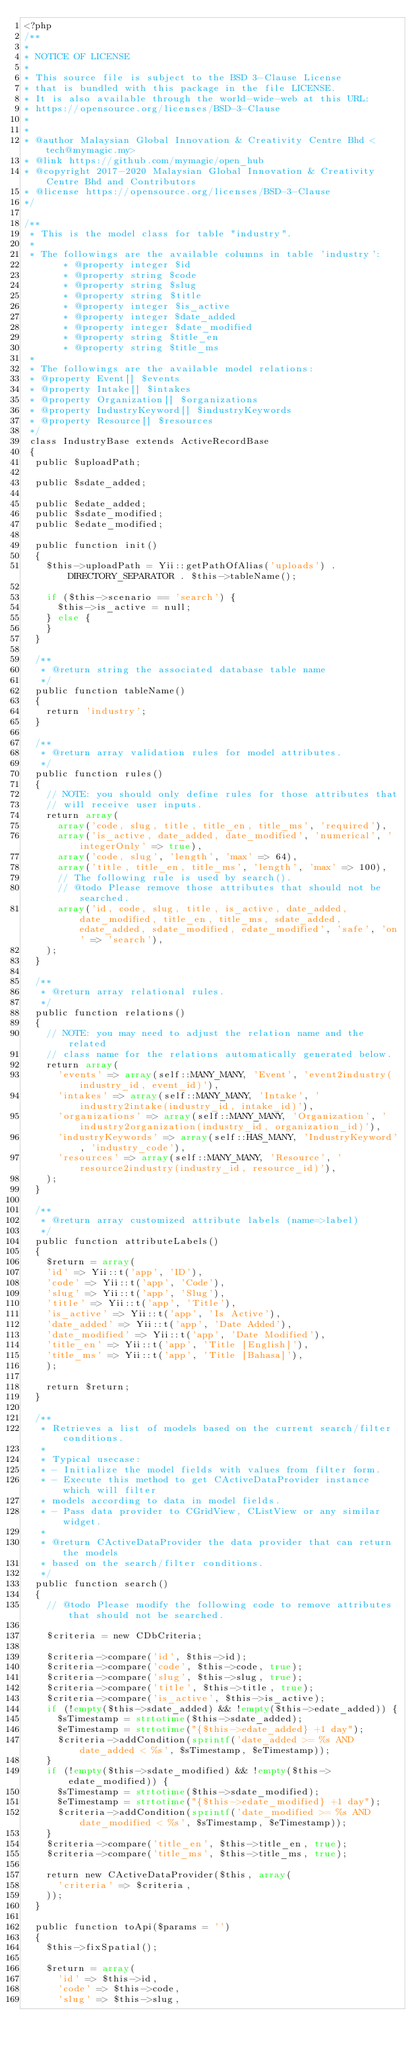Convert code to text. <code><loc_0><loc_0><loc_500><loc_500><_PHP_><?php
/**
*
* NOTICE OF LICENSE
*
* This source file is subject to the BSD 3-Clause License
* that is bundled with this package in the file LICENSE.
* It is also available through the world-wide-web at this URL:
* https://opensource.org/licenses/BSD-3-Clause
*
*
* @author Malaysian Global Innovation & Creativity Centre Bhd <tech@mymagic.my>
* @link https://github.com/mymagic/open_hub
* @copyright 2017-2020 Malaysian Global Innovation & Creativity Centre Bhd and Contributors
* @license https://opensource.org/licenses/BSD-3-Clause
*/

/**
 * This is the model class for table "industry".
 *
 * The followings are the available columns in table 'industry':
			 * @property integer $id
			 * @property string $code
			 * @property string $slug
			 * @property string $title
			 * @property integer $is_active
			 * @property integer $date_added
			 * @property integer $date_modified
			 * @property string $title_en
			 * @property string $title_ms
 *
 * The followings are the available model relations:
 * @property Event[] $events
 * @property Intake[] $intakes
 * @property Organization[] $organizations
 * @property IndustryKeyword[] $industryKeywords
 * @property Resource[] $resources
 */
 class IndustryBase extends ActiveRecordBase
 {
 	public $uploadPath;

 	public $sdate_added;

 	public $edate_added;
 	public $sdate_modified;
 	public $edate_modified;

 	public function init()
 	{
 		$this->uploadPath = Yii::getPathOfAlias('uploads') . DIRECTORY_SEPARATOR . $this->tableName();

 		if ($this->scenario == 'search') {
 			$this->is_active = null;
 		} else {
 		}
 	}

 	/**
 	 * @return string the associated database table name
 	 */
 	public function tableName()
 	{
 		return 'industry';
 	}

 	/**
 	 * @return array validation rules for model attributes.
 	 */
 	public function rules()
 	{
 		// NOTE: you should only define rules for those attributes that
 		// will receive user inputs.
 		return array(
			array('code, slug, title, title_en, title_ms', 'required'),
			array('is_active, date_added, date_modified', 'numerical', 'integerOnly' => true),
			array('code, slug', 'length', 'max' => 64),
			array('title, title_en, title_ms', 'length', 'max' => 100),
			// The following rule is used by search().
			// @todo Please remove those attributes that should not be searched.
			array('id, code, slug, title, is_active, date_added, date_modified, title_en, title_ms, sdate_added, edate_added, sdate_modified, edate_modified', 'safe', 'on' => 'search'),
		);
 	}

 	/**
 	 * @return array relational rules.
 	 */
 	public function relations()
 	{
 		// NOTE: you may need to adjust the relation name and the related
 		// class name for the relations automatically generated below.
 		return array(
			'events' => array(self::MANY_MANY, 'Event', 'event2industry(industry_id, event_id)'),
			'intakes' => array(self::MANY_MANY, 'Intake', 'industry2intake(industry_id, intake_id)'),
			'organizations' => array(self::MANY_MANY, 'Organization', 'industry2organization(industry_id, organization_id)'),
			'industryKeywords' => array(self::HAS_MANY, 'IndustryKeyword', 'industry_code'),
			'resources' => array(self::MANY_MANY, 'Resource', 'resource2industry(industry_id, resource_id)'),
		);
 	}

 	/**
 	 * @return array customized attribute labels (name=>label)
 	 */
 	public function attributeLabels()
 	{
 		$return = array(
		'id' => Yii::t('app', 'ID'),
		'code' => Yii::t('app', 'Code'),
		'slug' => Yii::t('app', 'Slug'),
		'title' => Yii::t('app', 'Title'),
		'is_active' => Yii::t('app', 'Is Active'),
		'date_added' => Yii::t('app', 'Date Added'),
		'date_modified' => Yii::t('app', 'Date Modified'),
		'title_en' => Yii::t('app', 'Title [English]'),
		'title_ms' => Yii::t('app', 'Title [Bahasa]'),
		);

 		return $return;
 	}

 	/**
 	 * Retrieves a list of models based on the current search/filter conditions.
 	 *
 	 * Typical usecase:
 	 * - Initialize the model fields with values from filter form.
 	 * - Execute this method to get CActiveDataProvider instance which will filter
 	 * models according to data in model fields.
 	 * - Pass data provider to CGridView, CListView or any similar widget.
 	 *
 	 * @return CActiveDataProvider the data provider that can return the models
 	 * based on the search/filter conditions.
 	 */
 	public function search()
 	{
 		// @todo Please modify the following code to remove attributes that should not be searched.

 		$criteria = new CDbCriteria;

 		$criteria->compare('id', $this->id);
 		$criteria->compare('code', $this->code, true);
 		$criteria->compare('slug', $this->slug, true);
 		$criteria->compare('title', $this->title, true);
 		$criteria->compare('is_active', $this->is_active);
 		if (!empty($this->sdate_added) && !empty($this->edate_added)) {
 			$sTimestamp = strtotime($this->sdate_added);
 			$eTimestamp = strtotime("{$this->edate_added} +1 day");
 			$criteria->addCondition(sprintf('date_added >= %s AND date_added < %s', $sTimestamp, $eTimestamp));
 		}
 		if (!empty($this->sdate_modified) && !empty($this->edate_modified)) {
 			$sTimestamp = strtotime($this->sdate_modified);
 			$eTimestamp = strtotime("{$this->edate_modified} +1 day");
 			$criteria->addCondition(sprintf('date_modified >= %s AND date_modified < %s', $sTimestamp, $eTimestamp));
 		}
 		$criteria->compare('title_en', $this->title_en, true);
 		$criteria->compare('title_ms', $this->title_ms, true);

 		return new CActiveDataProvider($this, array(
			'criteria' => $criteria,
		));
 	}

 	public function toApi($params = '')
 	{
 		$this->fixSpatial();

 		$return = array(
			'id' => $this->id,
			'code' => $this->code,
			'slug' => $this->slug,</code> 